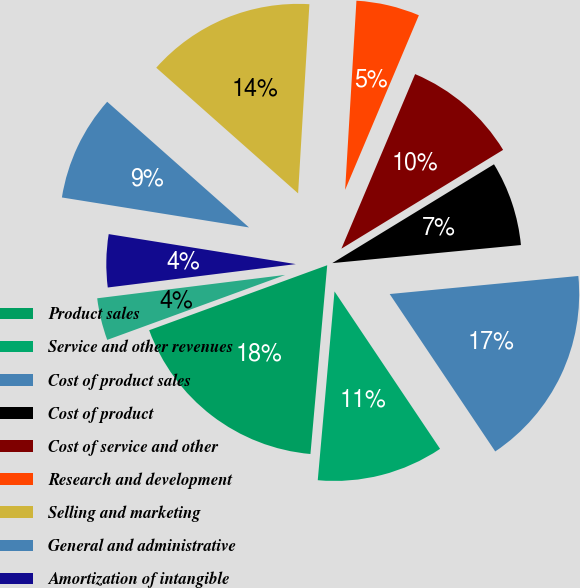Convert chart to OTSL. <chart><loc_0><loc_0><loc_500><loc_500><pie_chart><fcel>Product sales<fcel>Service and other revenues<fcel>Cost of product sales<fcel>Cost of product<fcel>Cost of service and other<fcel>Research and development<fcel>Selling and marketing<fcel>General and administrative<fcel>Amortization of intangible<fcel>Restructuring and divestiture<nl><fcel>18.02%<fcel>10.81%<fcel>17.12%<fcel>7.21%<fcel>9.91%<fcel>5.41%<fcel>14.41%<fcel>9.01%<fcel>4.5%<fcel>3.6%<nl></chart> 